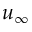Convert formula to latex. <formula><loc_0><loc_0><loc_500><loc_500>u _ { \infty }</formula> 